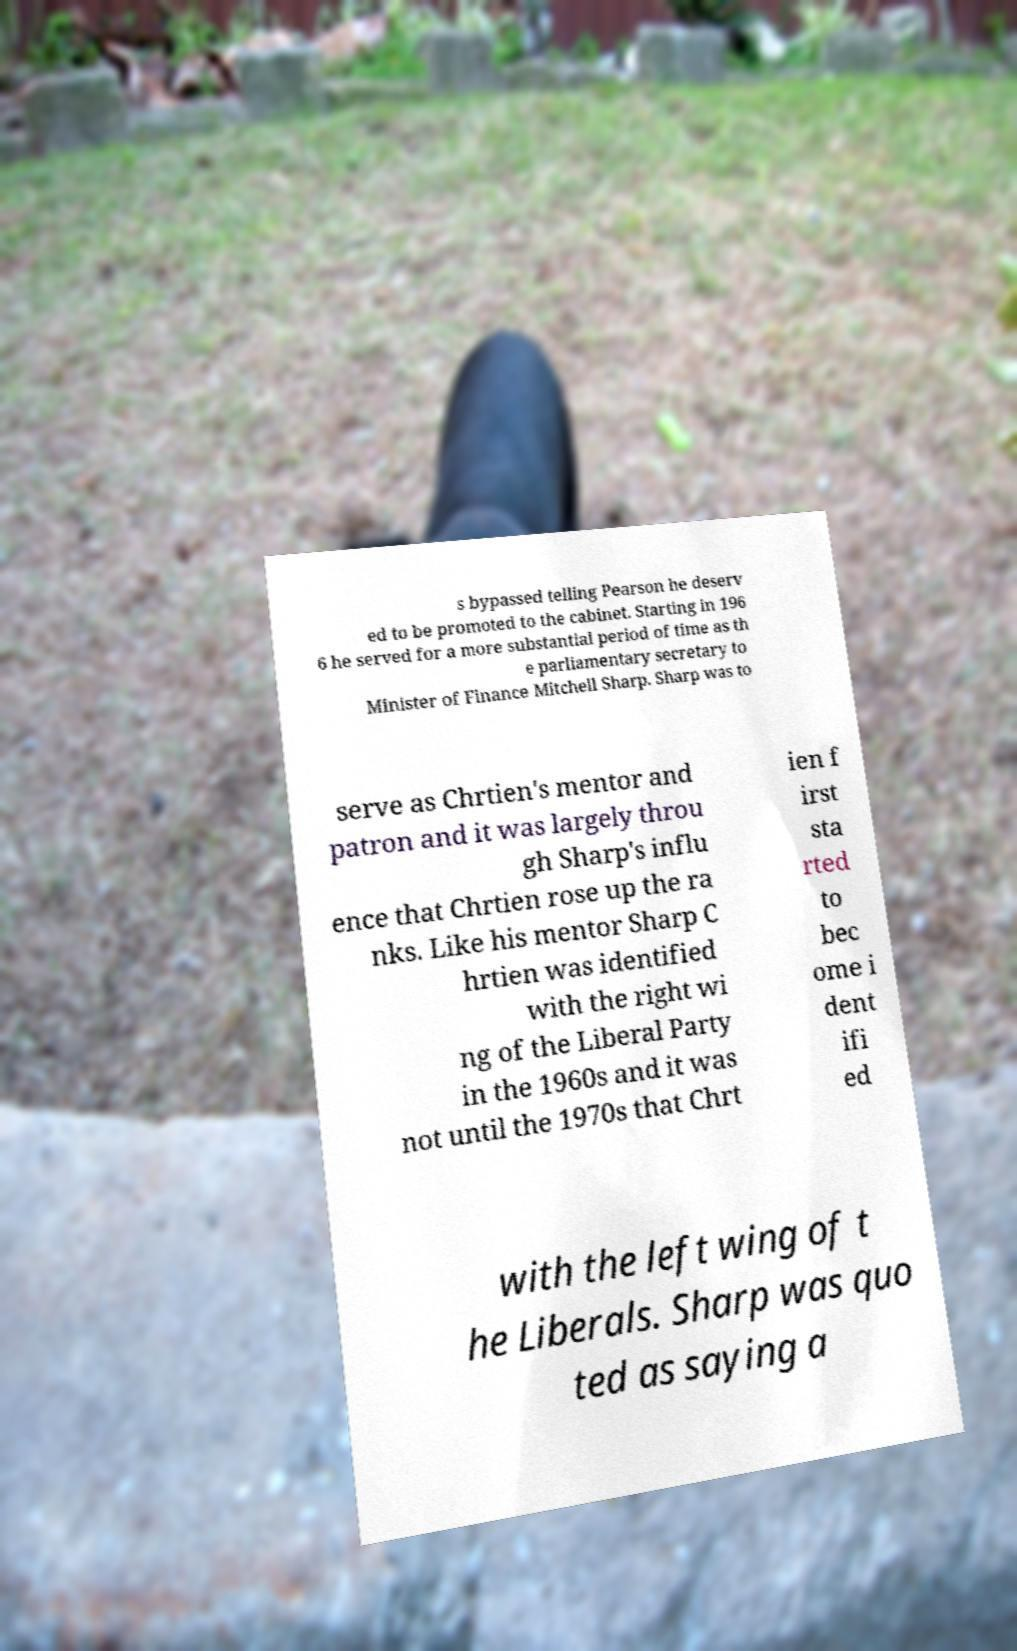Could you extract and type out the text from this image? s bypassed telling Pearson he deserv ed to be promoted to the cabinet. Starting in 196 6 he served for a more substantial period of time as th e parliamentary secretary to Minister of Finance Mitchell Sharp. Sharp was to serve as Chrtien's mentor and patron and it was largely throu gh Sharp's influ ence that Chrtien rose up the ra nks. Like his mentor Sharp C hrtien was identified with the right wi ng of the Liberal Party in the 1960s and it was not until the 1970s that Chrt ien f irst sta rted to bec ome i dent ifi ed with the left wing of t he Liberals. Sharp was quo ted as saying a 